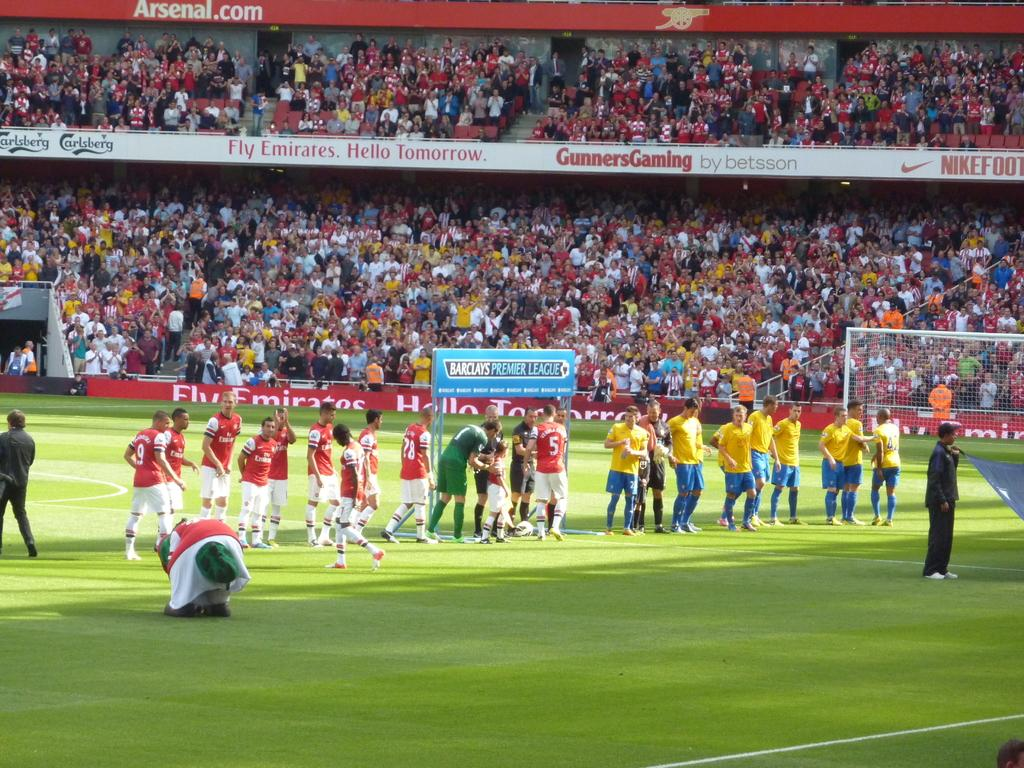<image>
Share a concise interpretation of the image provided. Group of soccer players on the field with advertisement for "Gunners Gaming". 